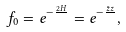Convert formula to latex. <formula><loc_0><loc_0><loc_500><loc_500>f _ { 0 } = { e } ^ { - \frac { 2 H } { } } = { e } ^ { - \frac { \bar { z } z } { } } ,</formula> 